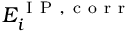Convert formula to latex. <formula><loc_0><loc_0><loc_500><loc_500>E _ { i } ^ { I P , c o r r }</formula> 